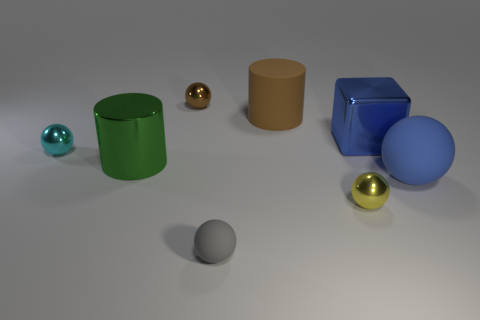Are there the same number of tiny rubber balls that are behind the gray sphere and tiny matte objects?
Offer a terse response. No. There is a metallic object that is to the left of the cylinder that is to the left of the big brown rubber cylinder; is there a big metallic thing that is to the left of it?
Provide a short and direct response. No. What is the tiny yellow thing made of?
Provide a succinct answer. Metal. What number of other objects are the same shape as the big blue rubber thing?
Keep it short and to the point. 4. Is the shape of the big green thing the same as the big blue metal thing?
Your response must be concise. No. How many objects are big objects right of the small matte thing or balls in front of the blue metallic block?
Provide a short and direct response. 6. What number of things are either blue blocks or brown things?
Give a very brief answer. 3. There is a rubber object in front of the blue matte ball; how many large rubber spheres are behind it?
Offer a very short reply. 1. What number of other things are there of the same size as the brown ball?
Your response must be concise. 3. What is the size of the thing that is the same color as the big block?
Offer a very short reply. Large. 